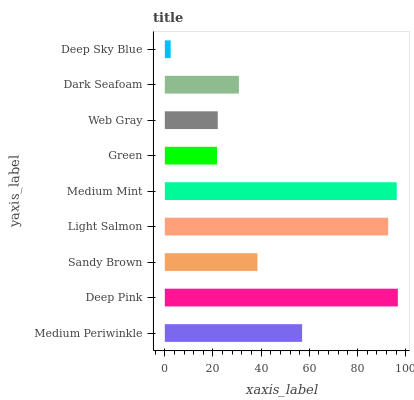Is Deep Sky Blue the minimum?
Answer yes or no. Yes. Is Deep Pink the maximum?
Answer yes or no. Yes. Is Sandy Brown the minimum?
Answer yes or no. No. Is Sandy Brown the maximum?
Answer yes or no. No. Is Deep Pink greater than Sandy Brown?
Answer yes or no. Yes. Is Sandy Brown less than Deep Pink?
Answer yes or no. Yes. Is Sandy Brown greater than Deep Pink?
Answer yes or no. No. Is Deep Pink less than Sandy Brown?
Answer yes or no. No. Is Sandy Brown the high median?
Answer yes or no. Yes. Is Sandy Brown the low median?
Answer yes or no. Yes. Is Medium Periwinkle the high median?
Answer yes or no. No. Is Medium Mint the low median?
Answer yes or no. No. 